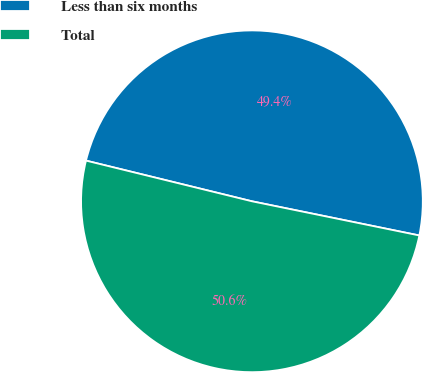<chart> <loc_0><loc_0><loc_500><loc_500><pie_chart><fcel>Less than six months<fcel>Total<nl><fcel>49.38%<fcel>50.62%<nl></chart> 